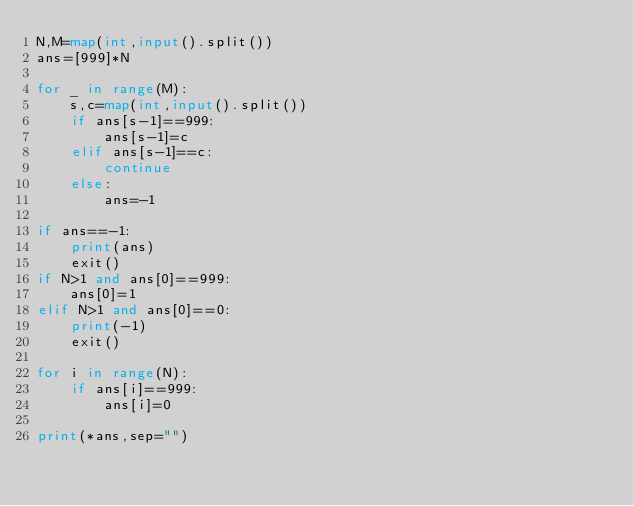<code> <loc_0><loc_0><loc_500><loc_500><_Python_>N,M=map(int,input().split())
ans=[999]*N
    
for _ in range(M):
    s,c=map(int,input().split())
    if ans[s-1]==999:
        ans[s-1]=c
    elif ans[s-1]==c:
        continue
    else:
        ans=-1

if ans==-1:
    print(ans)
    exit()
if N>1 and ans[0]==999:
    ans[0]=1
elif N>1 and ans[0]==0:
    print(-1)
    exit()

for i in range(N):
    if ans[i]==999:
        ans[i]=0

print(*ans,sep="")
</code> 